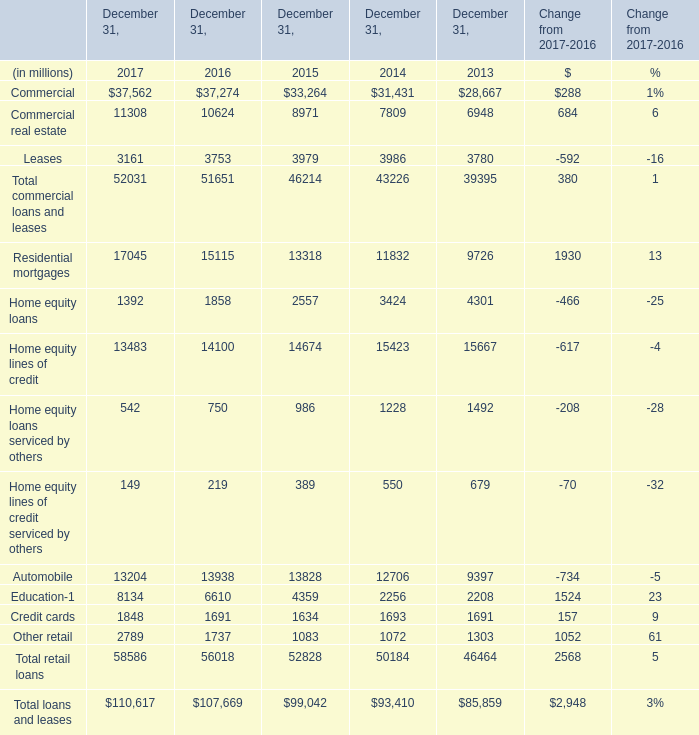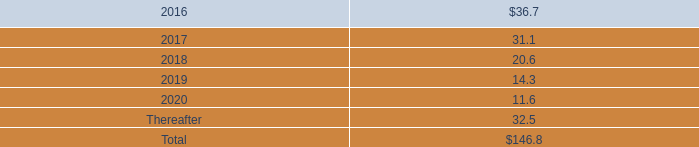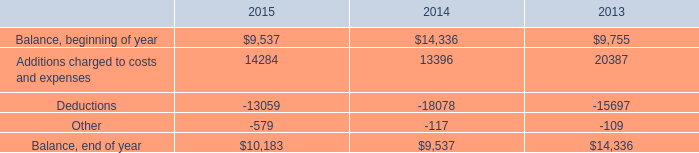What is the ratio of Commercial to the total in 2017? 
Computations: (37562 / 52031)
Answer: 0.72192. 